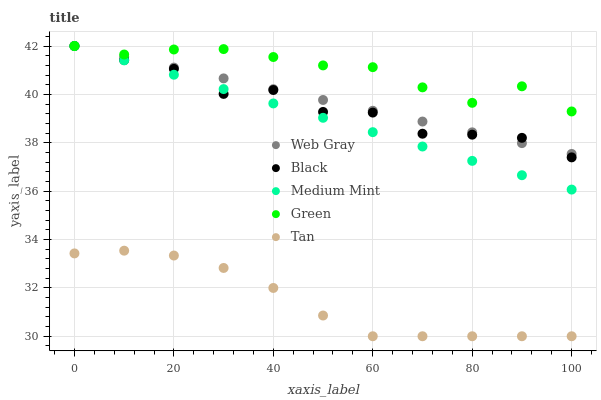Does Tan have the minimum area under the curve?
Answer yes or no. Yes. Does Green have the maximum area under the curve?
Answer yes or no. Yes. Does Green have the minimum area under the curve?
Answer yes or no. No. Does Tan have the maximum area under the curve?
Answer yes or no. No. Is Web Gray the smoothest?
Answer yes or no. Yes. Is Black the roughest?
Answer yes or no. Yes. Is Green the smoothest?
Answer yes or no. No. Is Green the roughest?
Answer yes or no. No. Does Tan have the lowest value?
Answer yes or no. Yes. Does Green have the lowest value?
Answer yes or no. No. Does Black have the highest value?
Answer yes or no. Yes. Does Tan have the highest value?
Answer yes or no. No. Is Tan less than Black?
Answer yes or no. Yes. Is Medium Mint greater than Tan?
Answer yes or no. Yes. Does Web Gray intersect Green?
Answer yes or no. Yes. Is Web Gray less than Green?
Answer yes or no. No. Is Web Gray greater than Green?
Answer yes or no. No. Does Tan intersect Black?
Answer yes or no. No. 